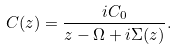<formula> <loc_0><loc_0><loc_500><loc_500>C ( z ) = \frac { i C _ { 0 } } { z - \Omega + i \Sigma ( z ) } .</formula> 